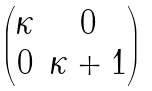<formula> <loc_0><loc_0><loc_500><loc_500>\begin{pmatrix} \kappa & 0 \\ 0 & \kappa + 1 \end{pmatrix}</formula> 